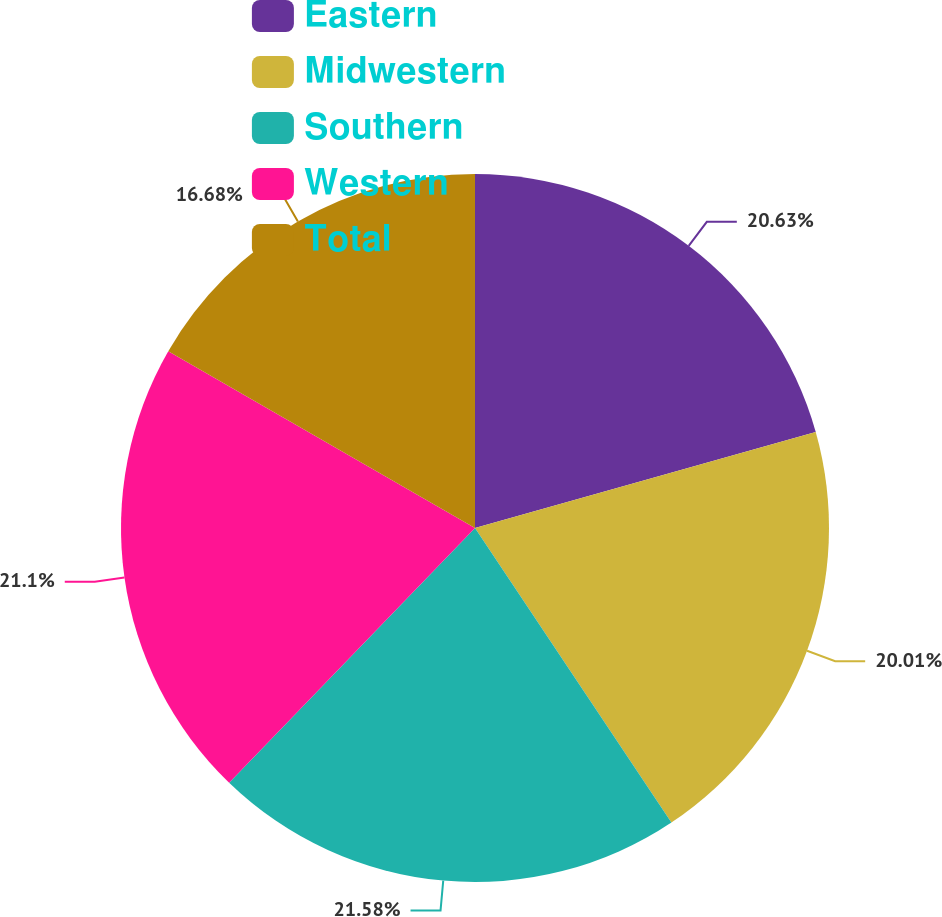<chart> <loc_0><loc_0><loc_500><loc_500><pie_chart><fcel>Eastern<fcel>Midwestern<fcel>Southern<fcel>Western<fcel>Total<nl><fcel>20.63%<fcel>20.01%<fcel>21.58%<fcel>21.1%<fcel>16.68%<nl></chart> 